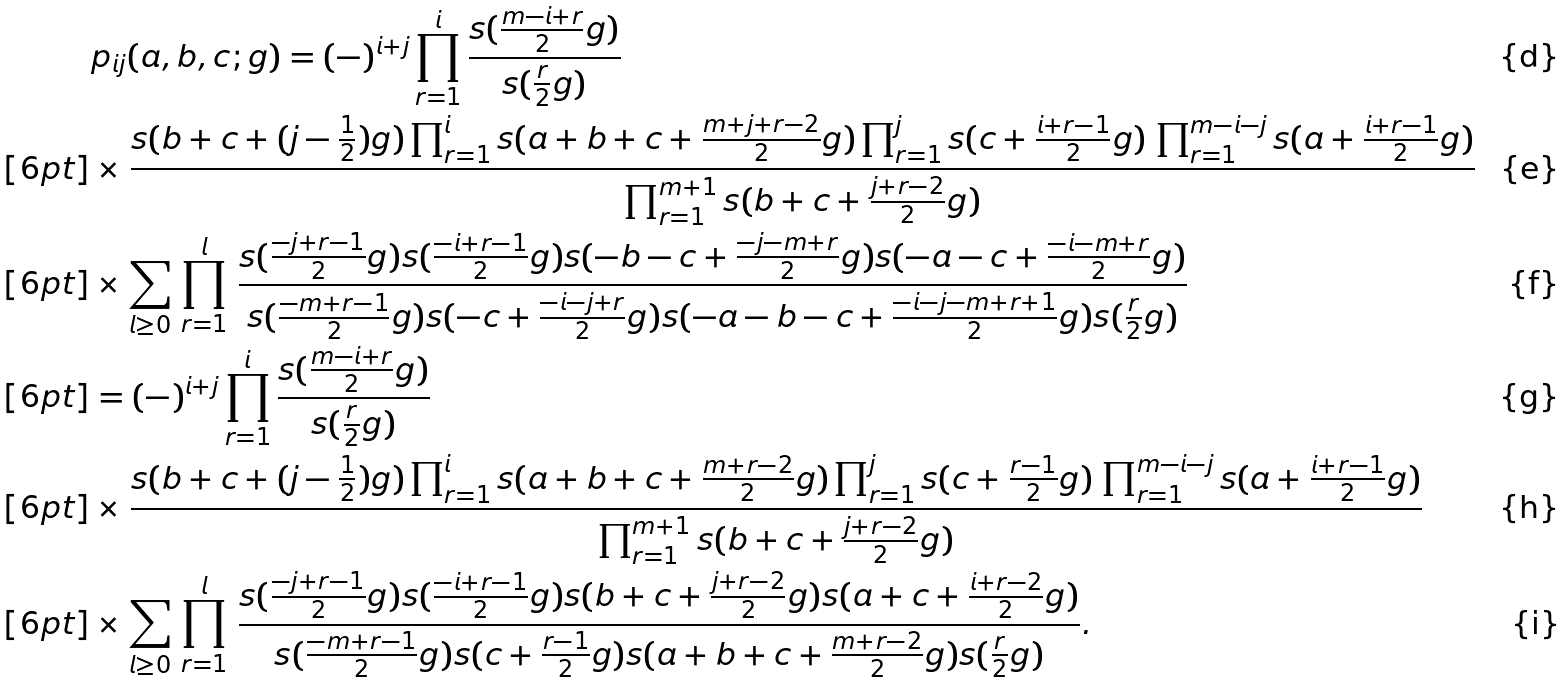<formula> <loc_0><loc_0><loc_500><loc_500>& p _ { i j } ( a , b , c ; g ) = ( - ) ^ { i + j } \prod _ { r = 1 } ^ { i } \frac { s ( \frac { m - i + r } { 2 } g ) } { s ( \frac { r } { 2 } g ) } \\ [ 6 p t ] & \times \frac { s ( b + c + ( j - \frac { 1 } { 2 } ) g ) \prod _ { r = 1 } ^ { i } s ( a + b + c + \frac { m + j + r - 2 } { 2 } g ) \prod _ { r = 1 } ^ { j } s ( c + \frac { i + r - 1 } { 2 } g ) \, \prod _ { r = 1 } ^ { m - i - j } s ( a + \frac { i + r - 1 } { 2 } g ) } { \prod _ { r = 1 } ^ { m + 1 } s ( b + c + \frac { j + r - 2 } { 2 } g ) } \\ [ 6 p t ] & \times \sum _ { l \geq 0 } \, \prod _ { r = 1 } ^ { l } \, \frac { s ( \frac { - j + r - 1 } { 2 } g ) s ( \frac { - i + r - 1 } { 2 } g ) s ( - b - c + \frac { - j - m + r } { 2 } g ) s ( - a - c + \frac { - i - m + r } { 2 } g ) } { s ( \frac { - m + r - 1 } { 2 } g ) s ( - c + \frac { - i - j + r } { 2 } g ) s ( - a - b - c + \frac { - i - j - m + r + 1 } { 2 } g ) s ( \frac { r } { 2 } g ) } \\ [ 6 p t ] & = ( - ) ^ { i + j } \prod _ { r = 1 } ^ { i } \frac { s ( \frac { m - i + r } { 2 } g ) } { s ( \frac { r } { 2 } g ) } \\ [ 6 p t ] & \times \frac { s ( b + c + ( j - \frac { 1 } { 2 } ) g ) \prod _ { r = 1 } ^ { i } s ( a + b + c + \frac { m + r - 2 } { 2 } g ) \prod _ { r = 1 } ^ { j } s ( c + \frac { r - 1 } { 2 } g ) \, \prod _ { r = 1 } ^ { m - i - j } s ( a + \frac { i + r - 1 } { 2 } g ) } { \prod _ { r = 1 } ^ { m + 1 } s ( b + c + \frac { j + r - 2 } { 2 } g ) } \\ [ 6 p t ] & \times \sum _ { l \geq 0 } \, \prod _ { r = 1 } ^ { l } \, \frac { s ( \frac { - j + r - 1 } { 2 } g ) s ( \frac { - i + r - 1 } { 2 } g ) s ( b + c + \frac { j + r - 2 } { 2 } g ) s ( a + c + \frac { i + r - 2 } { 2 } g ) } { s ( \frac { - m + r - 1 } { 2 } g ) s ( c + \frac { r - 1 } { 2 } g ) s ( a + b + c + \frac { m + r - 2 } { 2 } g ) s ( \frac { r } { 2 } g ) } .</formula> 